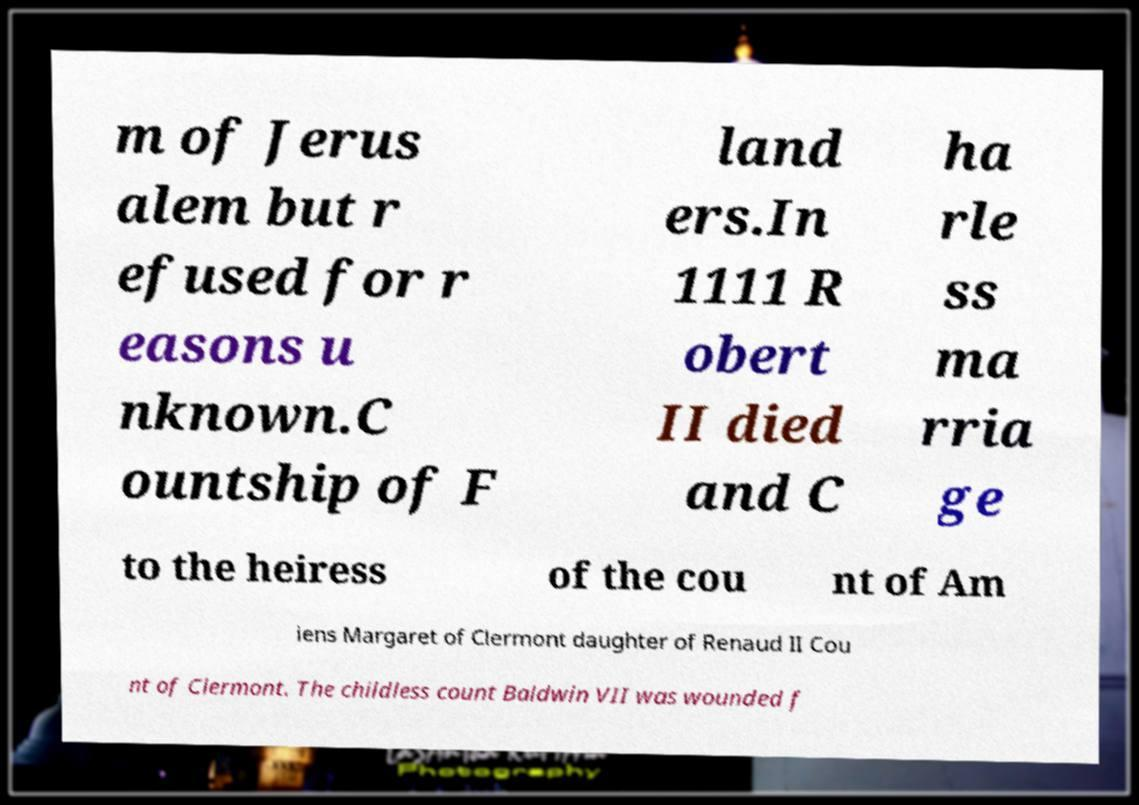Please identify and transcribe the text found in this image. m of Jerus alem but r efused for r easons u nknown.C ountship of F land ers.In 1111 R obert II died and C ha rle ss ma rria ge to the heiress of the cou nt of Am iens Margaret of Clermont daughter of Renaud II Cou nt of Clermont. The childless count Baldwin VII was wounded f 